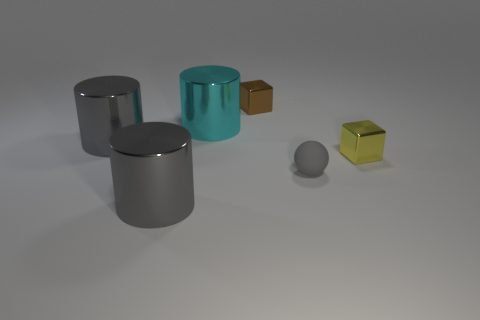Assuming this scene is a scale representation, what could these objects symbolize? If we take this scene as a scale representation, we could imagine it as a conceptual art piece. The varying sizes of the objects could represent diversity and individuality, while the different materials might symbolize the unique nature of elements in a community. Both the spacing and arrangement may suggest balance in diversity, emphasizing harmony despite differences. 